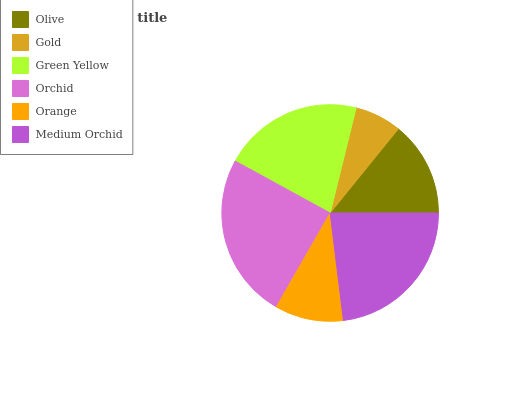Is Gold the minimum?
Answer yes or no. Yes. Is Orchid the maximum?
Answer yes or no. Yes. Is Green Yellow the minimum?
Answer yes or no. No. Is Green Yellow the maximum?
Answer yes or no. No. Is Green Yellow greater than Gold?
Answer yes or no. Yes. Is Gold less than Green Yellow?
Answer yes or no. Yes. Is Gold greater than Green Yellow?
Answer yes or no. No. Is Green Yellow less than Gold?
Answer yes or no. No. Is Green Yellow the high median?
Answer yes or no. Yes. Is Olive the low median?
Answer yes or no. Yes. Is Olive the high median?
Answer yes or no. No. Is Orchid the low median?
Answer yes or no. No. 